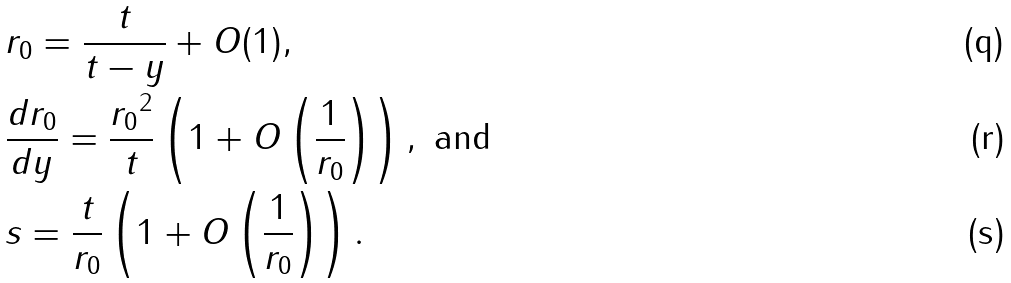Convert formula to latex. <formula><loc_0><loc_0><loc_500><loc_500>& r _ { 0 } = \frac { t } { t - y } + O ( 1 ) , & \\ & \frac { d r _ { 0 } } { d y } = \frac { { r _ { 0 } } ^ { 2 } } { t } \left ( 1 + O \left ( \frac { 1 } { r _ { 0 } } \right ) \right ) , \text { and} & \\ & s = \frac { t } { r _ { 0 } } \left ( 1 + O \left ( \frac { 1 } { r _ { 0 } } \right ) \right ) . &</formula> 